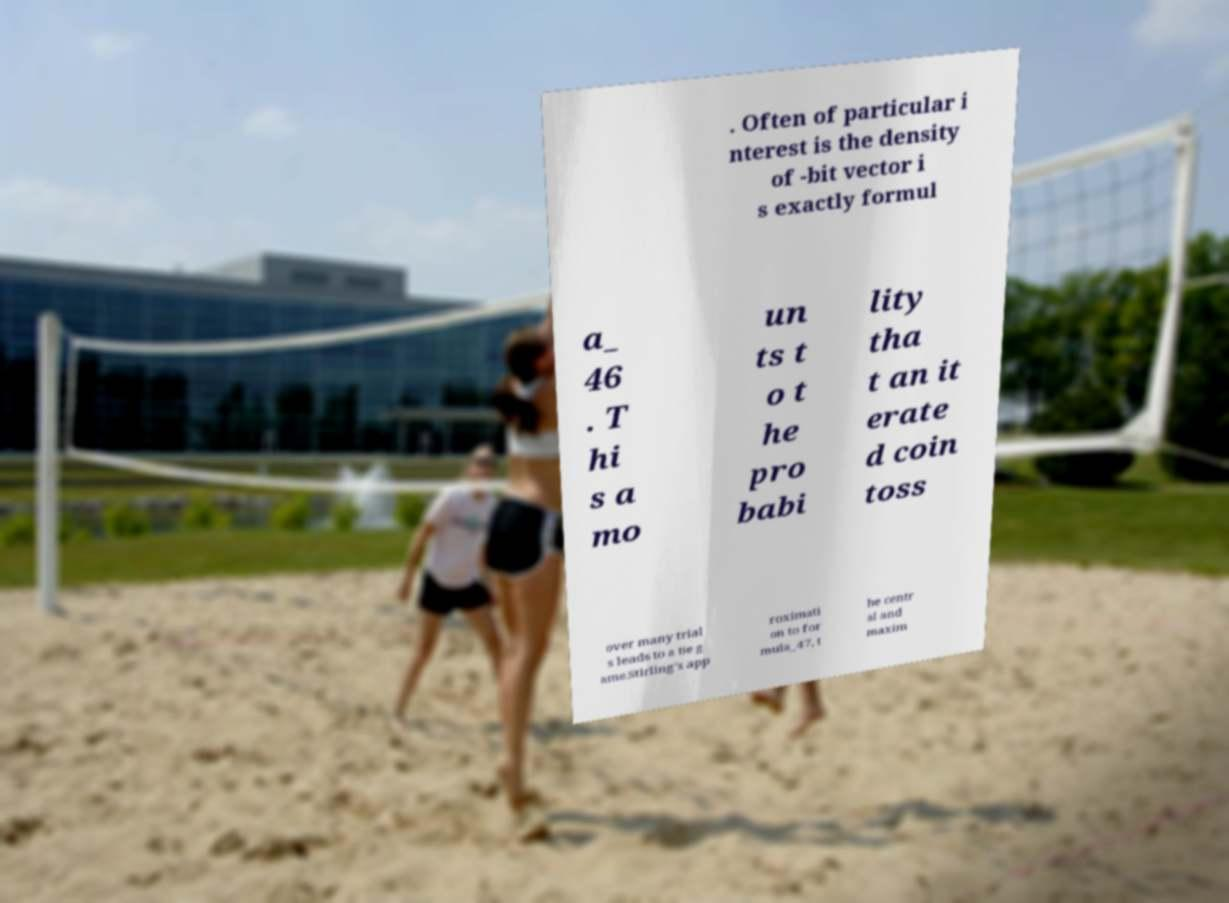For documentation purposes, I need the text within this image transcribed. Could you provide that? . Often of particular i nterest is the density of -bit vector i s exactly formul a_ 46 . T hi s a mo un ts t o t he pro babi lity tha t an it erate d coin toss over many trial s leads to a tie g ame.Stirling's app roximati on to for mula_47, t he centr al and maxim 